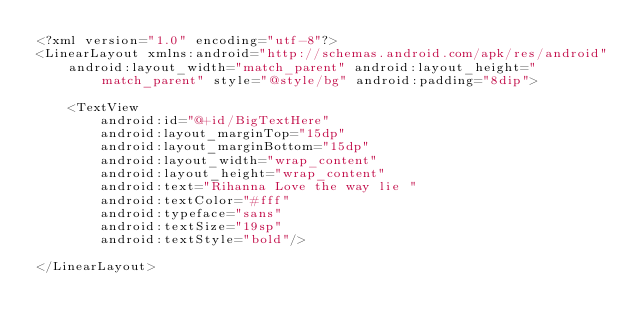Convert code to text. <code><loc_0><loc_0><loc_500><loc_500><_XML_><?xml version="1.0" encoding="utf-8"?>
<LinearLayout xmlns:android="http://schemas.android.com/apk/res/android"
    android:layout_width="match_parent" android:layout_height="match_parent" style="@style/bg" android:padding="8dip">

    <TextView
        android:id="@+id/BigTextHere"
        android:layout_marginTop="15dp"
        android:layout_marginBottom="15dp"
        android:layout_width="wrap_content"
        android:layout_height="wrap_content"
        android:text="Rihanna Love the way lie "
        android:textColor="#fff"
        android:typeface="sans"
        android:textSize="19sp"
        android:textStyle="bold"/>

</LinearLayout>
</code> 